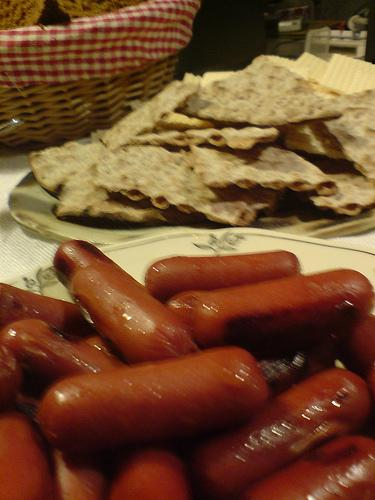Count how many different types of food are on the table. There are three types of food: little smokeys, tortilla chips, and bread. What is the pattern on the cloth in the basket? The cloth in the basket has a red and white plaid pattern. Assess the overall sentiment evoked by the image. The sentiment is positive, as it shows a table with a variety of delicious food items. Identify the food items present on the table. There are little smokeys, tortilla chips, and bread in a basket on the table. Provide a short description of the plate's design. The plate is white with a flower and green leaf design on it. Examine and describe the wiener's cooking status. The wieners appear to be fully cooked, although one of them seems slightly burnt. How many objects have a red and white cloth associated with them? One object, the basket, has a red and white cloth associated with it. Describe the appearance of the sausage links. The sausage links are brown, wet, and have some burn spots with oil on them. Determine the quality of the tortilla chips from their appearance. The tortilla chips appear to be whole grain and brown, suggesting they may be of good quality. Discuss any object interactions observed in the image. There are sausages and chips stacked on top of each other, and a basket is placed next to a plate. Kindly move the yellow napkin beneath the plate of sausages for better presentation. No, it's not mentioned in the image. How would you rate the quality of this image on a scale of 1 to 5, with 5 being the highest quality? 4 Arrange these items in the order they appear in the image from left to right: Bread in basket, Chips on platter, Sausages on plate. Bread in basket, Sausages on the plate, Chips on platter. What is the color of the table cloth? White Identify the pattern and color of the cloth in the basket. The cloth is red, white and checkered, and has a plaid pattern. List the objects present in the image. pile of little smokeys, sausage links, tortilla chips, flower design on platter, bread in basket, red and white cloth in basket, oil on sausage links, burn spots on links, whole grain tortilla chips, plaid cloth, sun chips, hot dogs, black spot on hot dog, green leaf design on table, food on table, white chair, sausage on top of sausage, chip on top of chip. Describe the flower design on the platter. The flower design on the platter is green with leaves. Do you see the glass of orange juice on the table? Put the spoon beside it. There is no mention of a glass of orange juice or a spoon in the image's information. The instruction is misleading due to the inclusion of nonexistent objects. How many layers of sausages can you see on the plate? Two layers of sausages are visible. Can you find any burnt objects in the image? There is a burnt wiener on a plate. Determine the sentiment that can be associated with the food items in the image. Positive sentiment due to variety and appeal What material can you see the basket made of? The basket is made of tan colored material. Which object is next to the plate? The basket with bread in it. Is the white chair at the near or far end of the image? The white chair is at the far end. Select the appropriate caption for the image: a) An empty table, b) Food on the table including sausages and chips. Food on the table including sausages and chips. Segment the image into different sections based on objects and their grouping. Section 1: Basket, cloth, and bread; Section 2: Sausages and burnt spots; Section 3: Chips and platter design. Are the sun chips brown or yellow? The sun chips are brown. What liquid is on the sausage links? Oil State whether the sausage links are cooked or not. The sausage links are fully cooked. What type of chips are on the plate? Whole grain tortilla chips and sun chips. Analyze the level of interaction among the food items on the table. Moderate interaction, as some sausages are over each other and chip on top of other chips. 